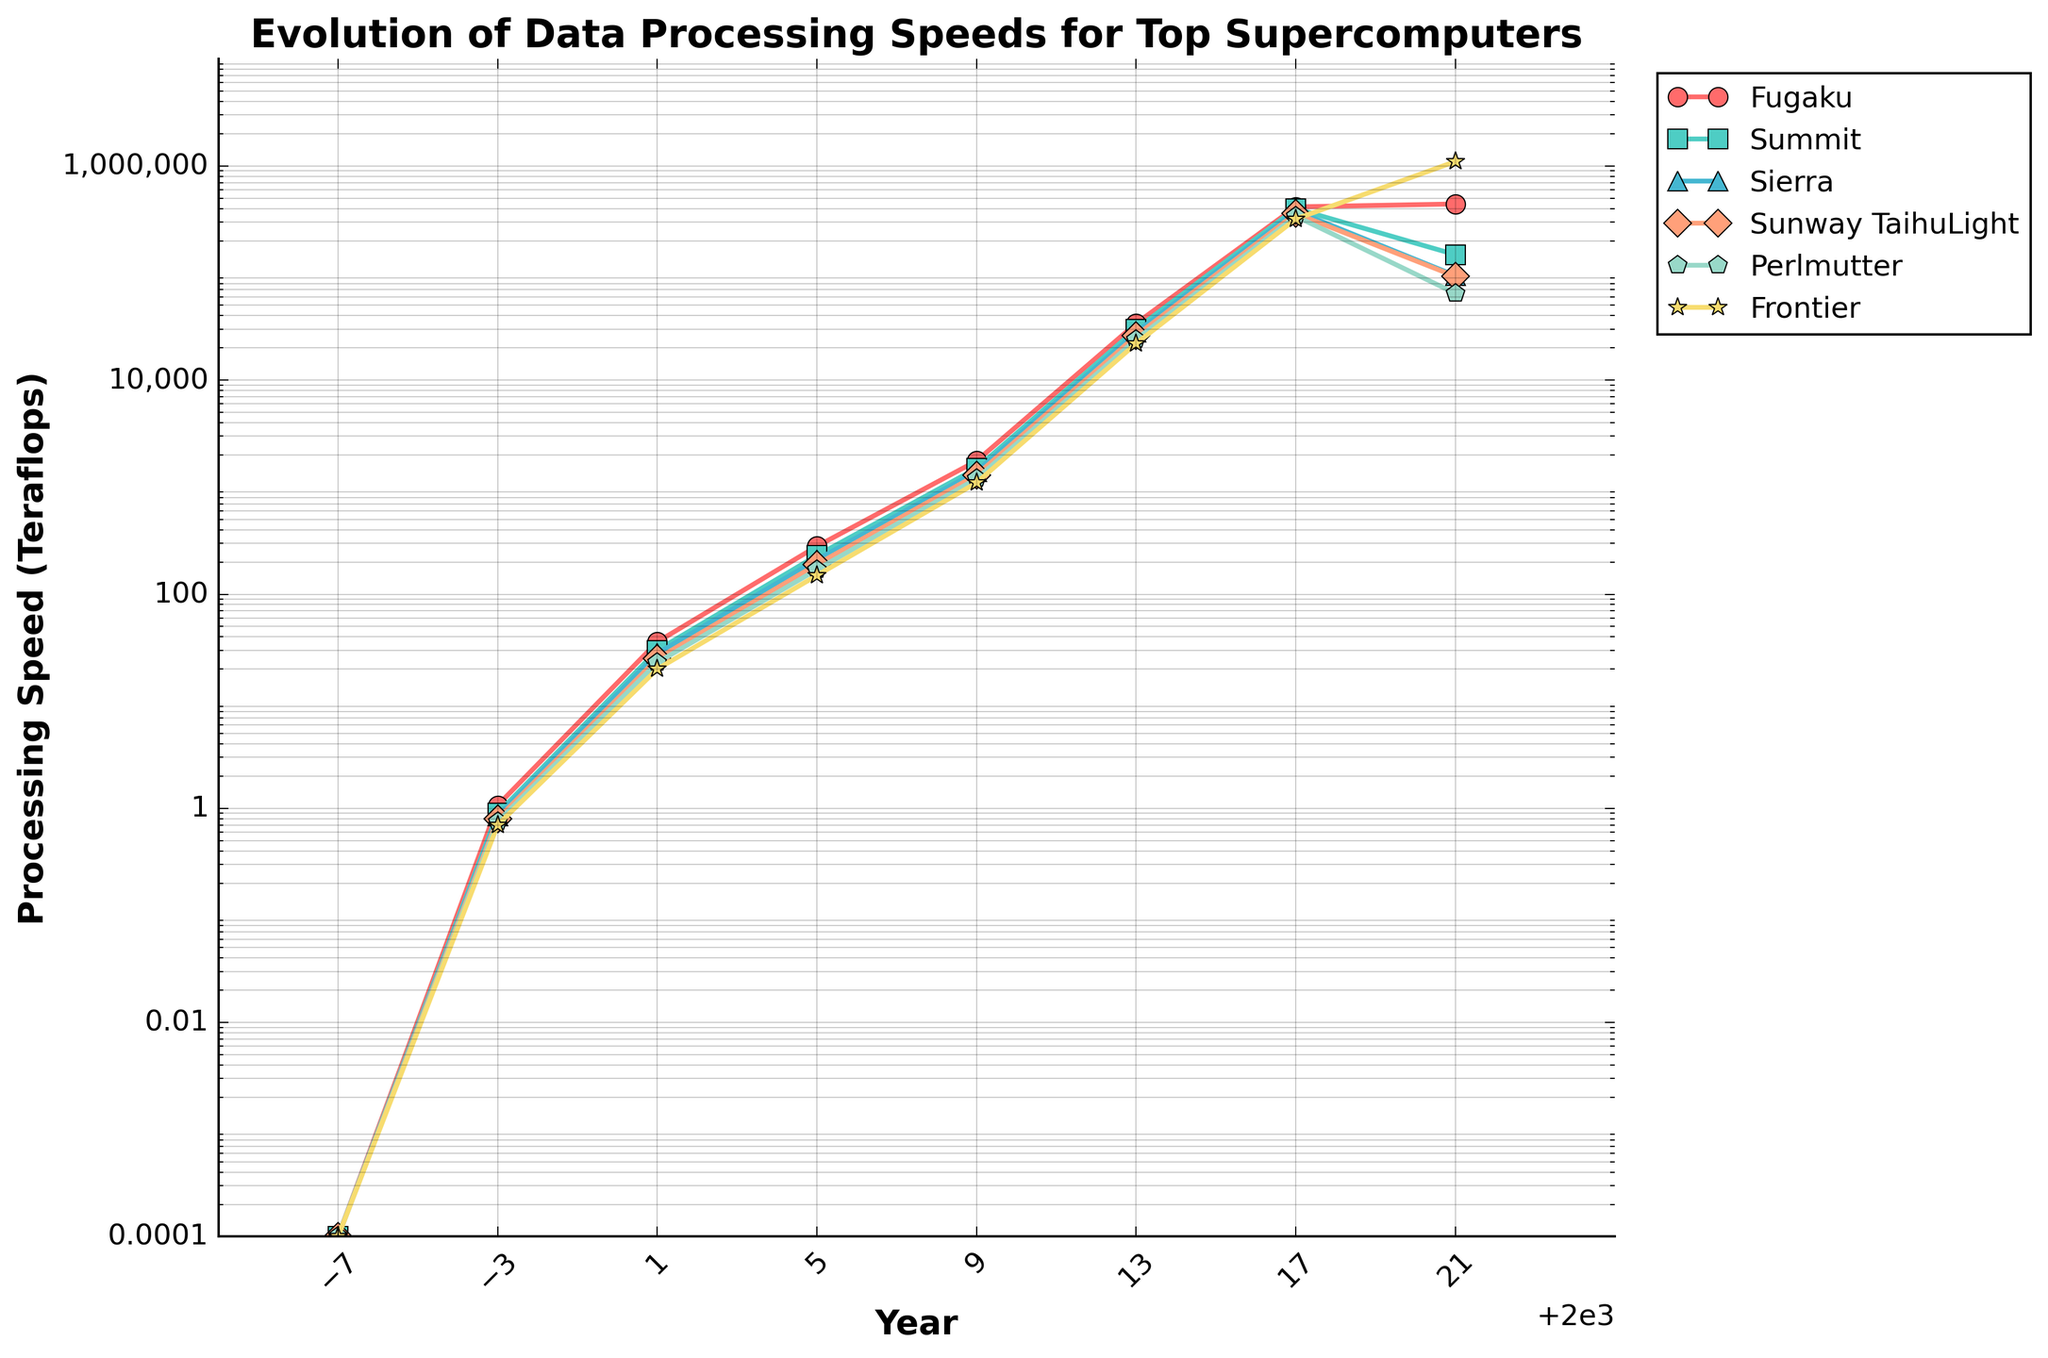What was the processing speed of the supercomputer "Fugaku" in 1993? From the figure, locate the Fugaku line and find the processing speed value for the year 1993
Answer: 0.0001 teraflops Which supercomputer had the highest processing speed in 2021? Observe the lines at the year 2021 and identify which one reaches the highest point
Answer: Frontier How much did the processing speed of Summit increase from 1997 to 2021? Identify the processing speeds of Summit in 1997 and 2021, then compute the difference (148600 - 0.9)
Answer: 148599.1 teraflops Compare the processing speeds of Sierra and Perlmutter in 2013. Which one was faster? Look at the values of Sierra and Perlmutter for the year 2013 and compare them
Answer: Sierra What is the range of data processing speeds for Sunway TaihuLight over the past three decades? Note the minimum and maximum values of Sunway TaihuLight's processing speed from 1993 to 2021 and compute the range by subtracting the minimum from the maximum
Answer: 92999.9999 teraflops Which supercomputer exhibited the most consistent growth in processing speed? By observing the visual patterns of the lines, determine which supercomputer's line shows a steady increase without major fluctuations
Answer: Summit By how much did the processing speed of Perlmutter change from 2005 to 2021? Identify Perlmutter's processing speeds in 2005 and 2021, then compute the difference (1102000 - 150)
Answer: 1101850 teraflops What trend can be observed in the processing speeds of the top supercomputers over the past three decades? Consider the general direction and pattern of all the lines from 1993 to 2021 to detect an overall trend
Answer: Increasing exponentially Which supercomputer had the slowest processing speed in 2009? Identify the lowest data point among all supercomputers in the year 2009
Answer: Frontier Which two supercomputers had the closest processing speeds in 2017? Check the values for all supercomputers in 2017 and find the pair with the smallest difference in their speeds
Answer: Summit and Sierra 